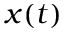<formula> <loc_0><loc_0><loc_500><loc_500>x ( t )</formula> 